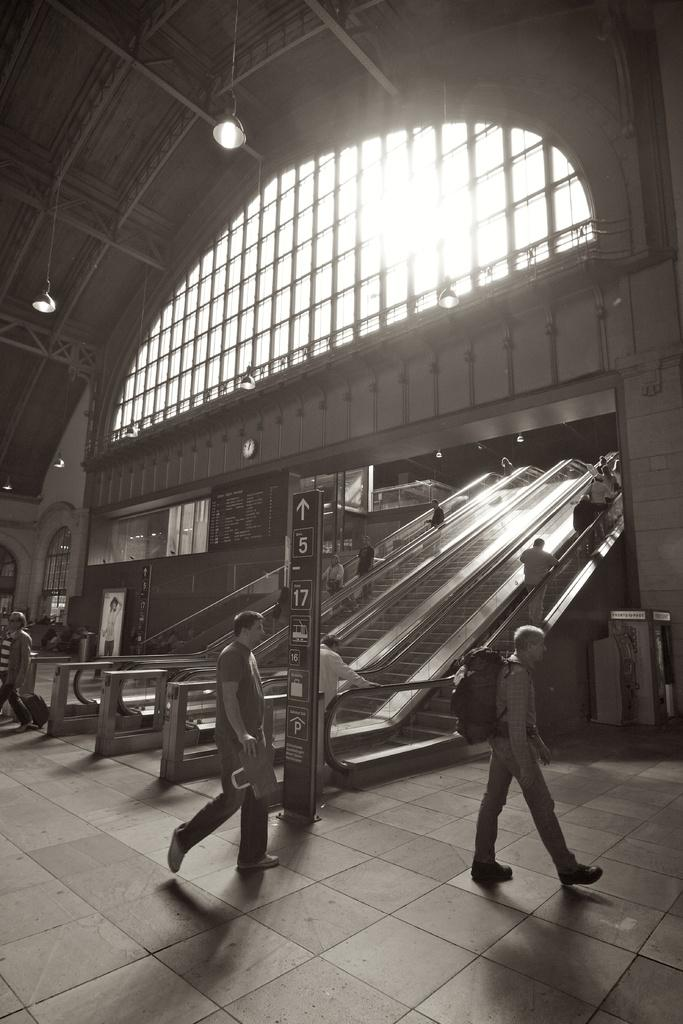What is the color scheme of the image? The image is black and white. What are the people in the image doing? People are walking in the image. What type of transportation is present in the image? There are escalators in the image. Are there any people using the escalators? Yes, people are present on the escalators. What can be seen at the top of the escalators? There are lights at the top of the escalators. What type of pen is being used by the person in the image? There is no pen visible in the image. Can you tell me how many cribs are present in the image? There are no cribs present in the image. 